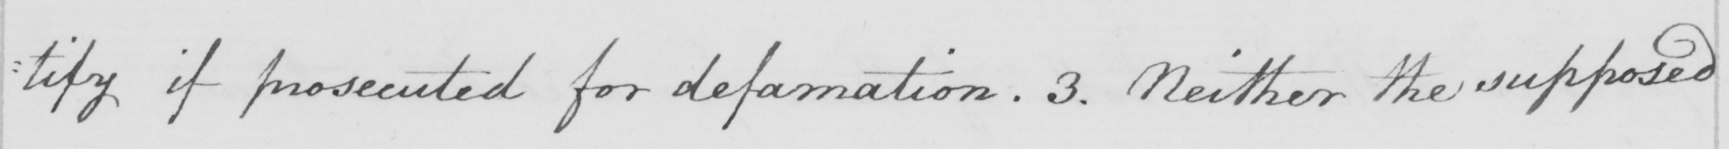What text is written in this handwritten line? : tify if prosecuted for defamation . 3 . Neither the supposed 